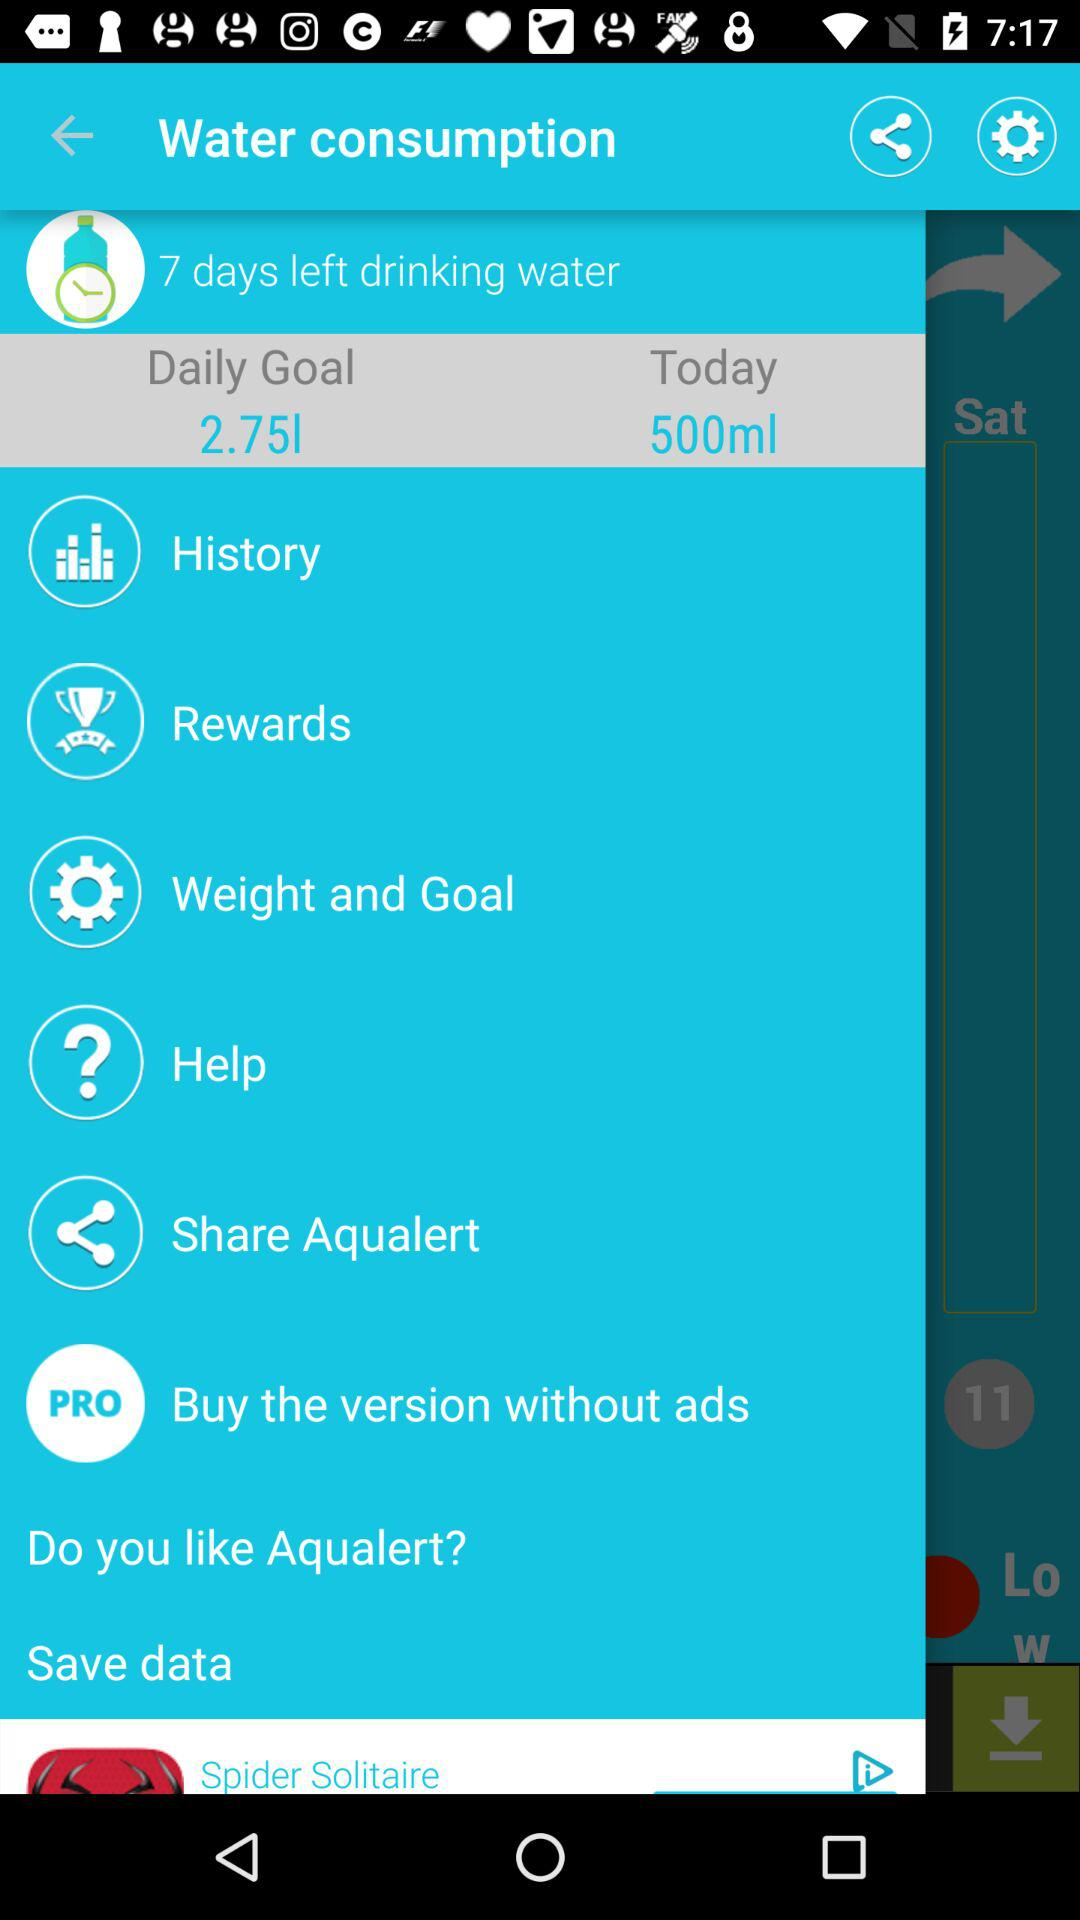How many days are left for drinking water? There are 7 days left for drinking water. 